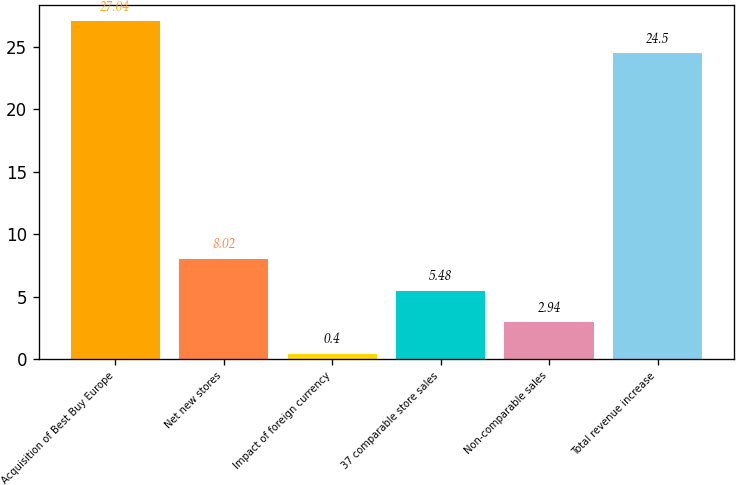Convert chart. <chart><loc_0><loc_0><loc_500><loc_500><bar_chart><fcel>Acquisition of Best Buy Europe<fcel>Net new stores<fcel>Impact of foreign currency<fcel>37 comparable store sales<fcel>Non-comparable sales<fcel>Total revenue increase<nl><fcel>27.04<fcel>8.02<fcel>0.4<fcel>5.48<fcel>2.94<fcel>24.5<nl></chart> 